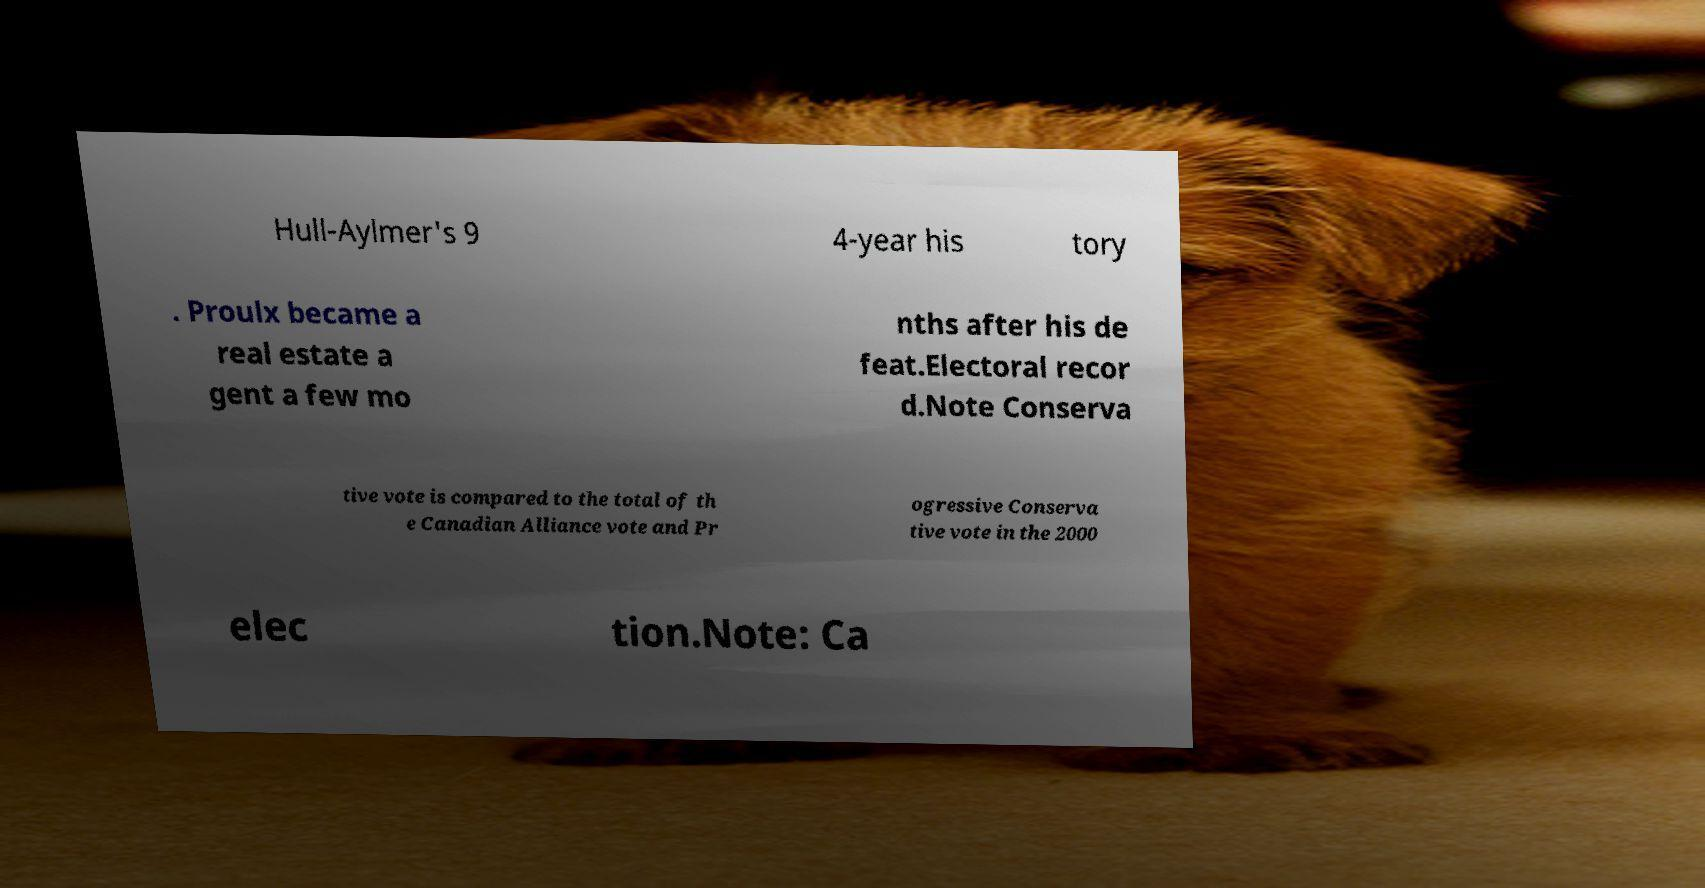Please read and relay the text visible in this image. What does it say? Hull-Aylmer's 9 4-year his tory . Proulx became a real estate a gent a few mo nths after his de feat.Electoral recor d.Note Conserva tive vote is compared to the total of th e Canadian Alliance vote and Pr ogressive Conserva tive vote in the 2000 elec tion.Note: Ca 